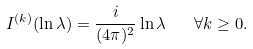<formula> <loc_0><loc_0><loc_500><loc_500>I ^ { ( k ) } ( \ln \lambda ) = \frac { i } { ( 4 \pi ) ^ { 2 } } \ln \lambda \quad \forall k \geq 0 .</formula> 